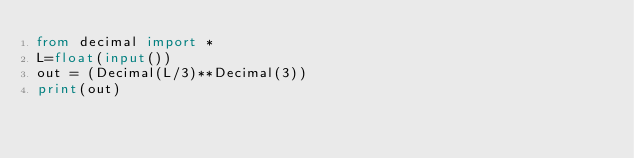Convert code to text. <code><loc_0><loc_0><loc_500><loc_500><_Python_>from decimal import *
L=float(input())
out = (Decimal(L/3)**Decimal(3))
print(out)</code> 